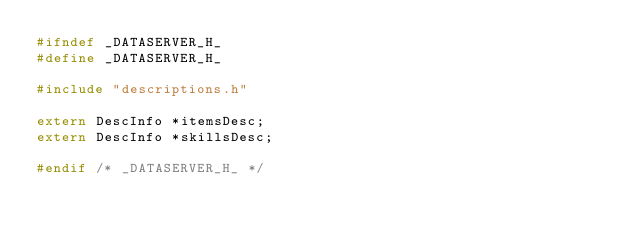<code> <loc_0><loc_0><loc_500><loc_500><_C_>#ifndef _DATASERVER_H_
#define _DATASERVER_H_

#include "descriptions.h"

extern DescInfo *itemsDesc;
extern DescInfo *skillsDesc;

#endif /* _DATASERVER_H_ */
</code> 